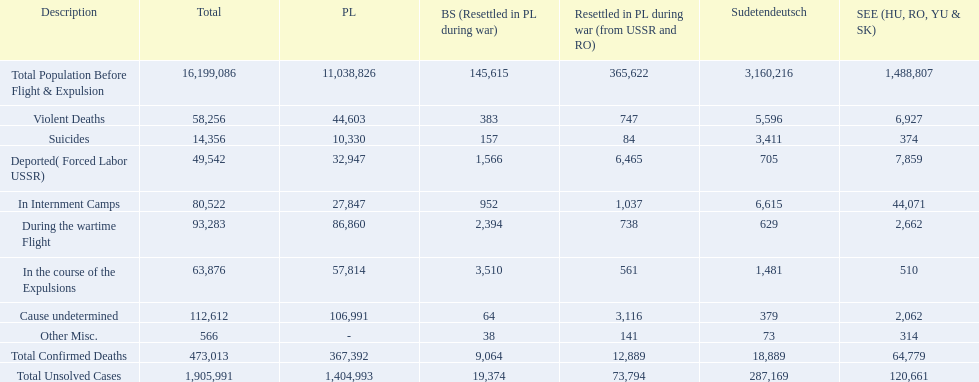What were the total number of confirmed deaths? 473,013. Of these, how many were violent? 58,256. 